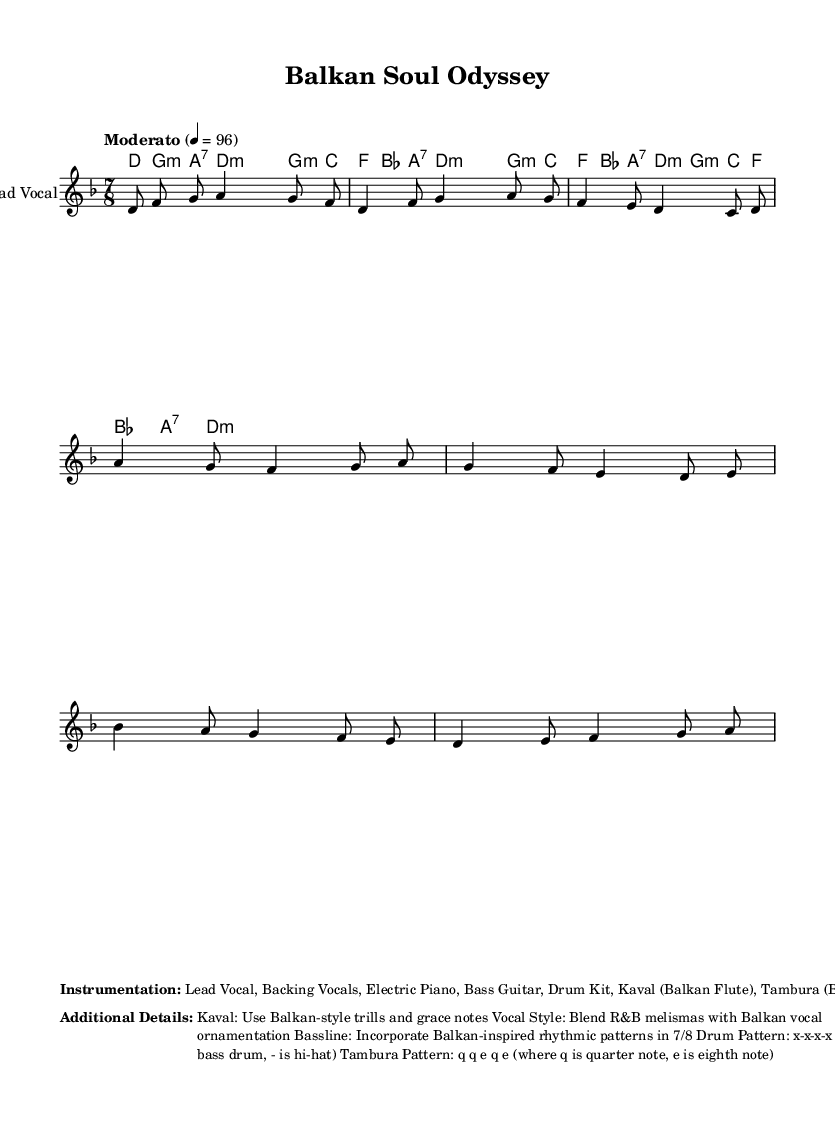What is the key signature of this music? The key signature is D minor, which is indicated by one flat (B flat).
Answer: D minor What is the time signature of this music? The time signature is 7/8, which means there are seven eighth notes per measure.
Answer: 7/8 What tempo marking is indicated in the music? The tempo marking is "Moderato" with a metronome marking of quarter note equals 96 beats per minute.
Answer: Moderato How many measures are there in the chorus section? The chorus consists of four measures, as indicated by the sequence of musical notes and corresponding chord changes.
Answer: 4 What is the main rhythmic feel of the bassline in this song? The bassline incorporates a Balkan-inspired rhythmic pattern, specifically in a 7/8 feel which is characterized by its irregular grouping of beats.
Answer: 7/8 What instruments are used in this arrangement? The instrumentation includes Lead Vocal, Backing Vocals, Electric Piano, Bass Guitar, Drum Kit, Kaval, and Tambura.
Answer: Lead Vocal, Backing Vocals, Electric Piano, Bass Guitar, Drum Kit, Kaval, Tambura How does the vocal style blend different musical traditions? The vocal style blends R&B melismas with Balkan vocal ornamentation, creating a fusion effect that draws on both genres' unique characteristics.
Answer: R&B melismas and Balkan ornamentation 